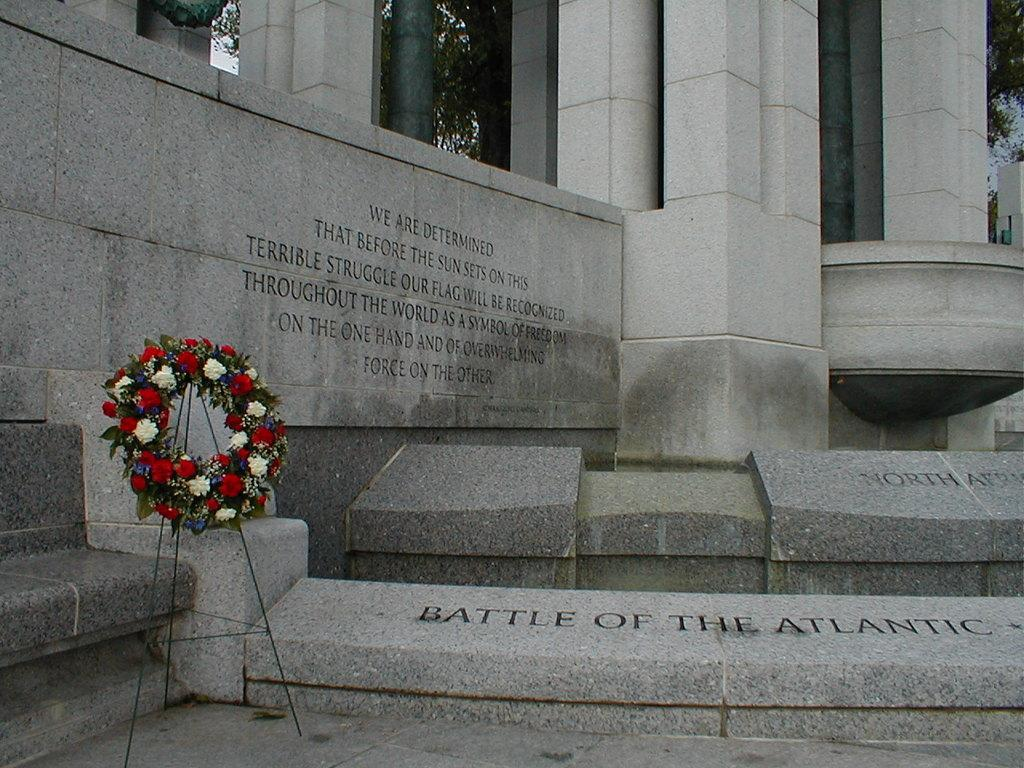What type of structure is present in the image? There is a building in the image. What decorative item can be seen in the image? There is a garland on a stand in the image. Are there any words or letters in the image? Yes, there is text in the image. What type of natural elements are visible in the image? Trees are visible at the top of the image. Can you tell if the image was taken during the day or night? The image appears to have been taken during the day. What type of zinc is used to make the garland in the image? There is no mention of zinc or any material used to make the garland in the image. How does the care for the trees in the image affect their growth? The image does not provide any information about the care or growth of the trees. 